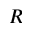Convert formula to latex. <formula><loc_0><loc_0><loc_500><loc_500>R</formula> 